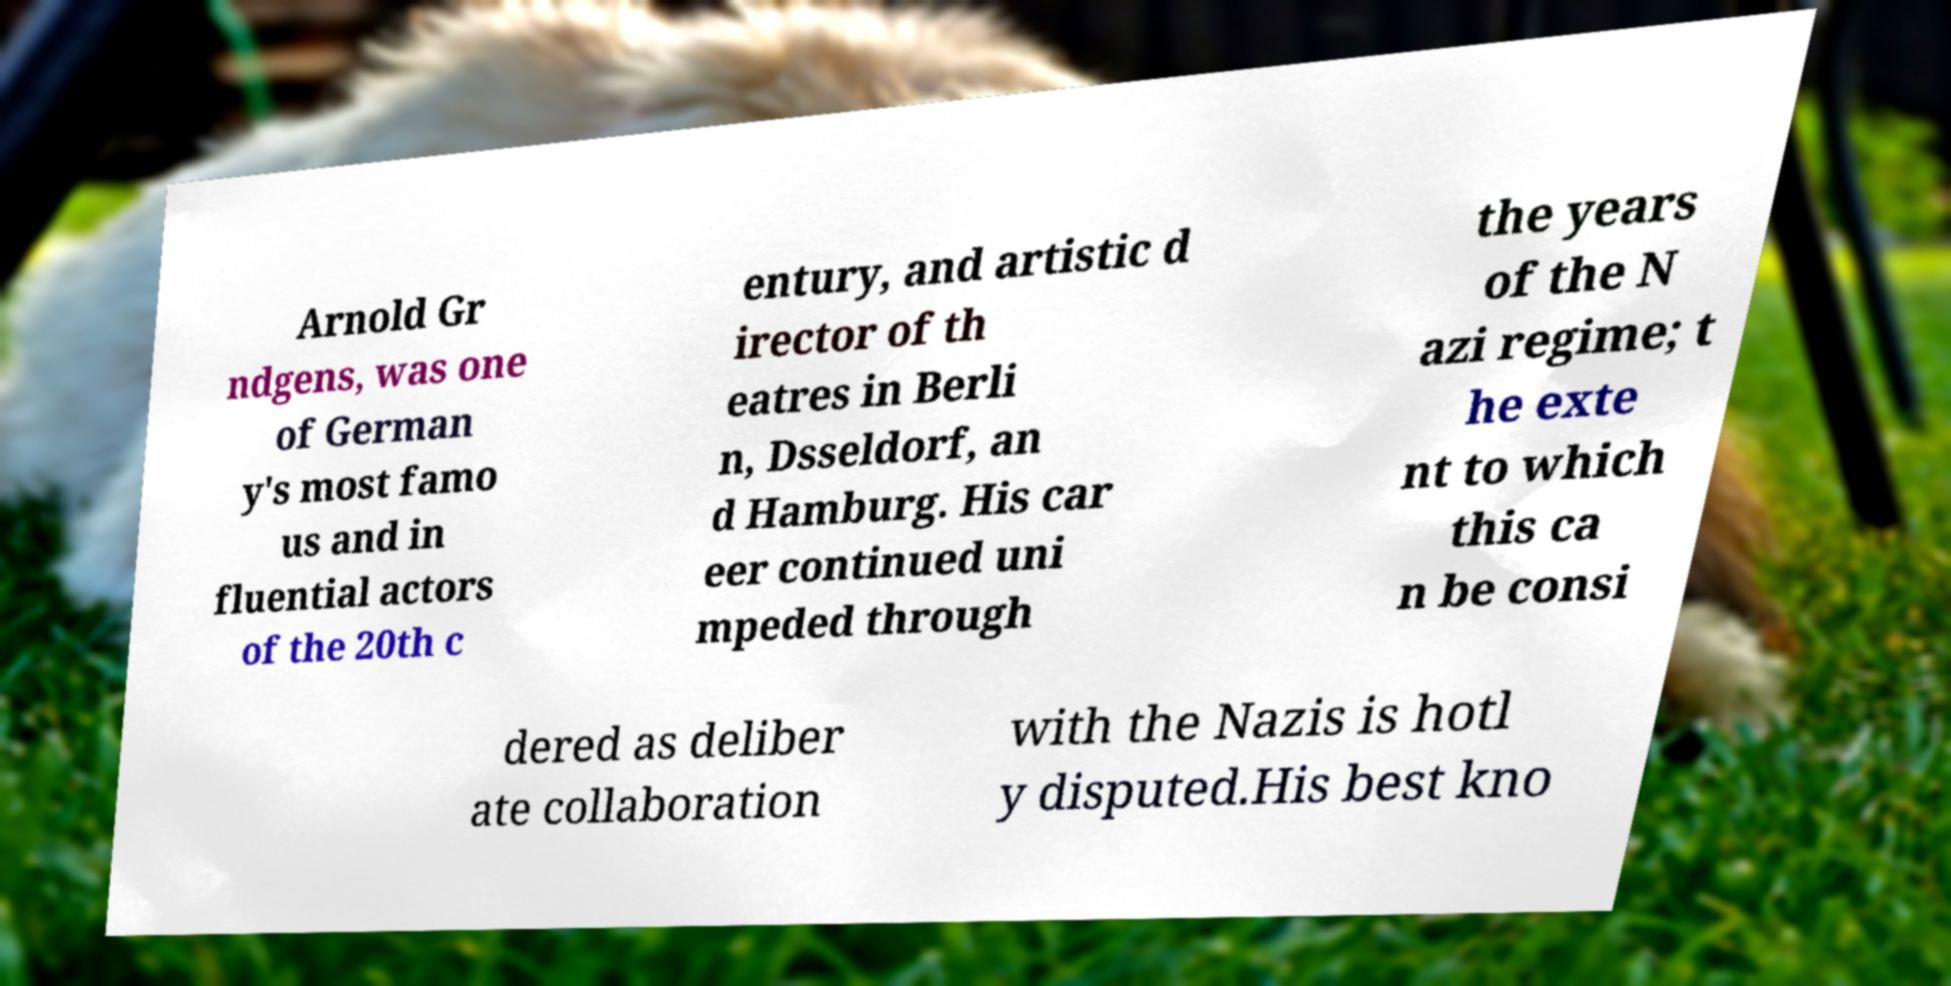Could you assist in decoding the text presented in this image and type it out clearly? Arnold Gr ndgens, was one of German y's most famo us and in fluential actors of the 20th c entury, and artistic d irector of th eatres in Berli n, Dsseldorf, an d Hamburg. His car eer continued uni mpeded through the years of the N azi regime; t he exte nt to which this ca n be consi dered as deliber ate collaboration with the Nazis is hotl y disputed.His best kno 